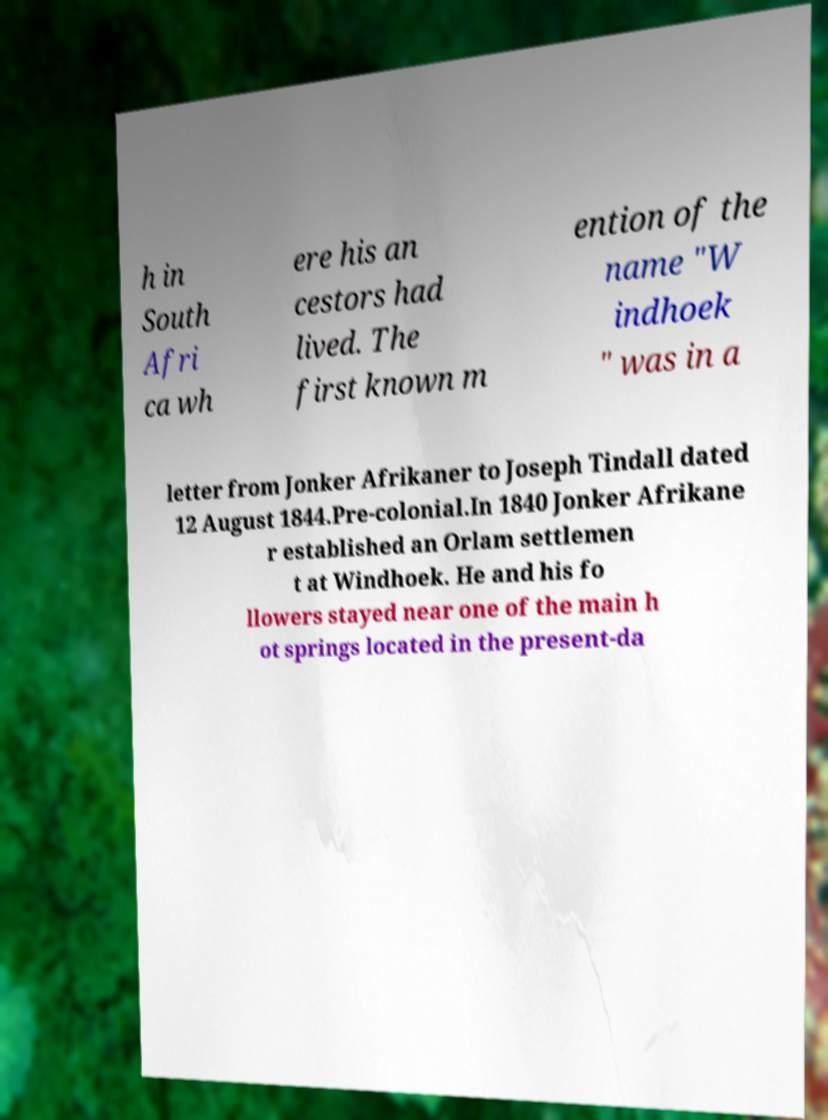Please read and relay the text visible in this image. What does it say? h in South Afri ca wh ere his an cestors had lived. The first known m ention of the name "W indhoek " was in a letter from Jonker Afrikaner to Joseph Tindall dated 12 August 1844.Pre-colonial.In 1840 Jonker Afrikane r established an Orlam settlemen t at Windhoek. He and his fo llowers stayed near one of the main h ot springs located in the present-da 